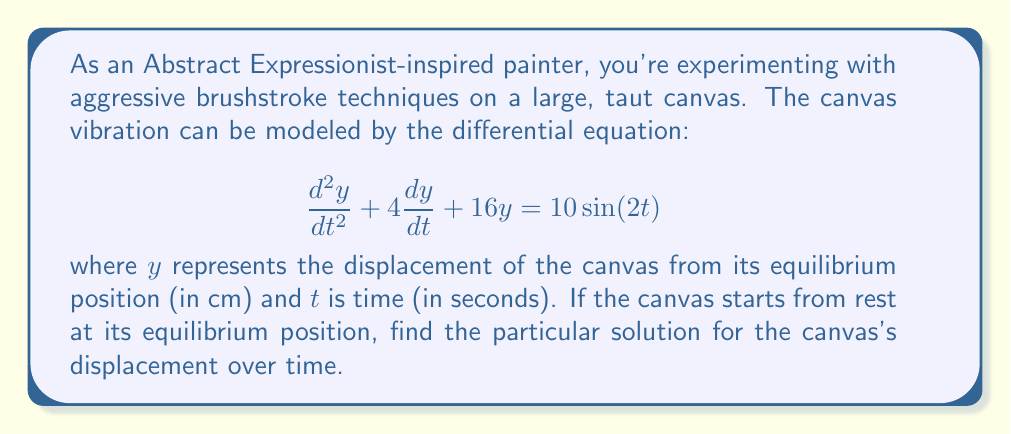Give your solution to this math problem. To solve this differential equation, we'll follow these steps:

1) First, we recognize this as a non-homogeneous second-order linear differential equation with constant coefficients. The general form is:

   $$ay'' + by' + cy = f(t)$$

   where $a=1$, $b=4$, $c=16$, and $f(t) = 10\sin(2t)$.

2) The particular solution will have the form:

   $$y_p = A\sin(2t) + B\cos(2t)$$

   because the forcing function is sinusoidal.

3) We need to find $y_p'$ and $y_p''$:

   $$y_p' = 2A\cos(2t) - 2B\sin(2t)$$
   $$y_p'' = -4A\sin(2t) - 4B\cos(2t)$$

4) Substitute these into the original equation:

   $$(-4A\sin(2t) - 4B\cos(2t)) + 4(2A\cos(2t) - 2B\sin(2t)) + 16(A\sin(2t) + B\cos(2t)) = 10\sin(2t)$$

5) Simplify and group $\sin(2t)$ and $\cos(2t)$ terms:

   $$(12A - 8B)\sin(2t) + (12B + 8A)\cos(2t) = 10\sin(2t)$$

6) Equate coefficients:

   $$12A - 8B = 10$$
   $$12B + 8A = 0$$

7) Solve this system of equations:

   From the second equation: $B = -\frac{2A}{3}$
   
   Substitute into the first equation:
   
   $$12A - 8(-\frac{2A}{3}) = 10$$
   $$12A + \frac{16A}{3} = 10$$
   $$\frac{52A}{3} = 10$$
   $$A = \frac{30}{52} = \frac{15}{26}$$

   Then, $B = -\frac{2}{3} \cdot \frac{15}{26} = -\frac{5}{13}$

8) Therefore, the particular solution is:

   $$y_p = \frac{15}{26}\sin(2t) - \frac{5}{13}\cos(2t)$$

This is the steady-state solution. To get the complete solution, we'd need to add the complementary solution (solution to the homogeneous equation) and apply initial conditions. However, as we're asked for the particular solution, this is our final answer.
Answer: $$y_p = \frac{15}{26}\sin(2t) - \frac{5}{13}\cos(2t)$$ 